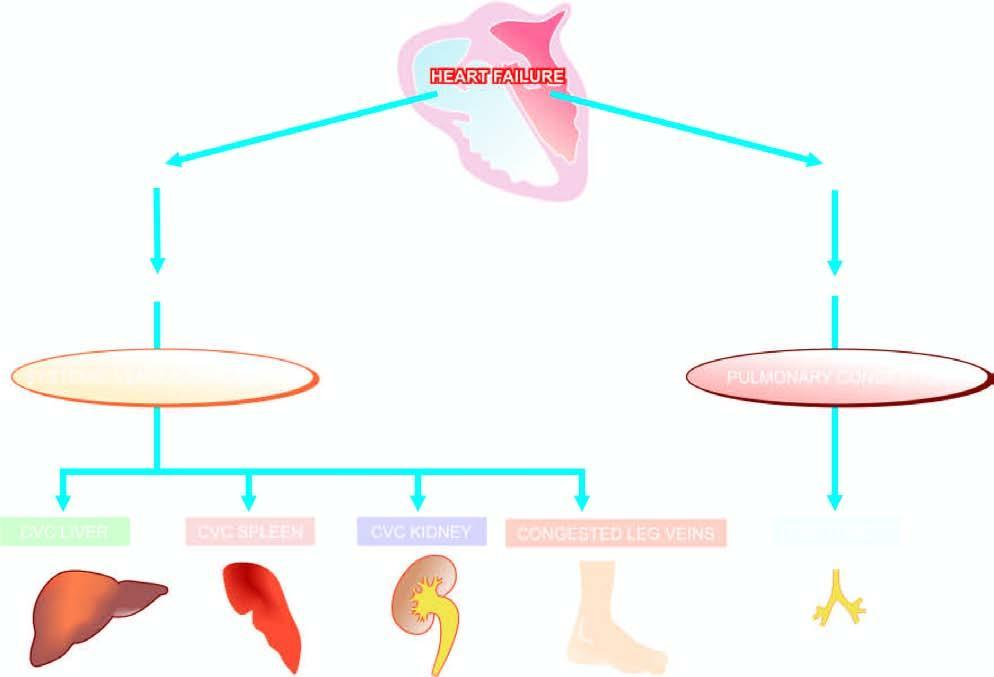what is schematic representation of mechanisms involved in?
Answer the question using a single word or phrase. Chronic venous congestion (cvc) different organs 